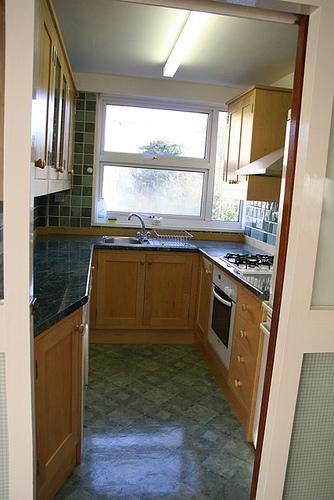Is this a wood floor?
Concise answer only. No. What kind of light is mounted on the ceiling?
Give a very brief answer. Fluorescent. What kind of stove is it?
Short answer required. Gas. 